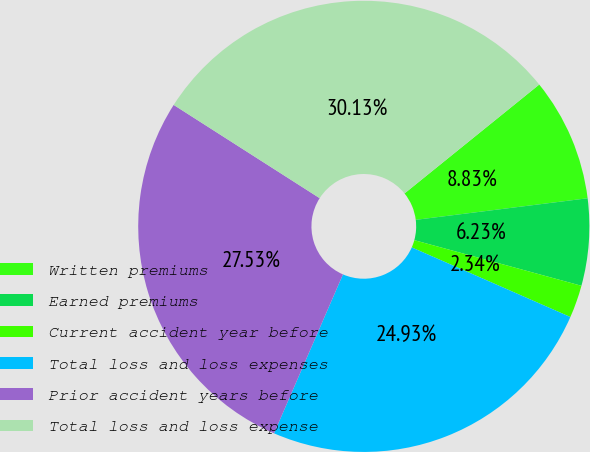Convert chart to OTSL. <chart><loc_0><loc_0><loc_500><loc_500><pie_chart><fcel>Written premiums<fcel>Earned premiums<fcel>Current accident year before<fcel>Total loss and loss expenses<fcel>Prior accident years before<fcel>Total loss and loss expense<nl><fcel>8.83%<fcel>6.23%<fcel>2.34%<fcel>24.93%<fcel>27.53%<fcel>30.13%<nl></chart> 